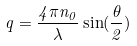Convert formula to latex. <formula><loc_0><loc_0><loc_500><loc_500>q = \frac { 4 \pi n _ { 0 } } { \lambda } \sin ( \frac { \theta } { 2 } )</formula> 